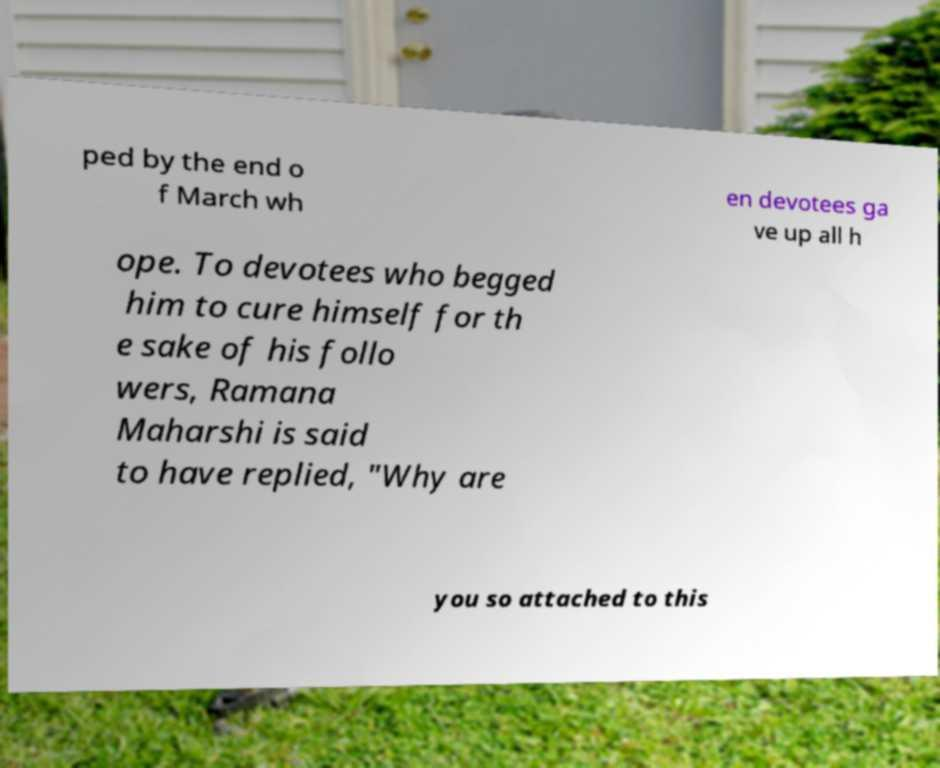Please identify and transcribe the text found in this image. ped by the end o f March wh en devotees ga ve up all h ope. To devotees who begged him to cure himself for th e sake of his follo wers, Ramana Maharshi is said to have replied, "Why are you so attached to this 